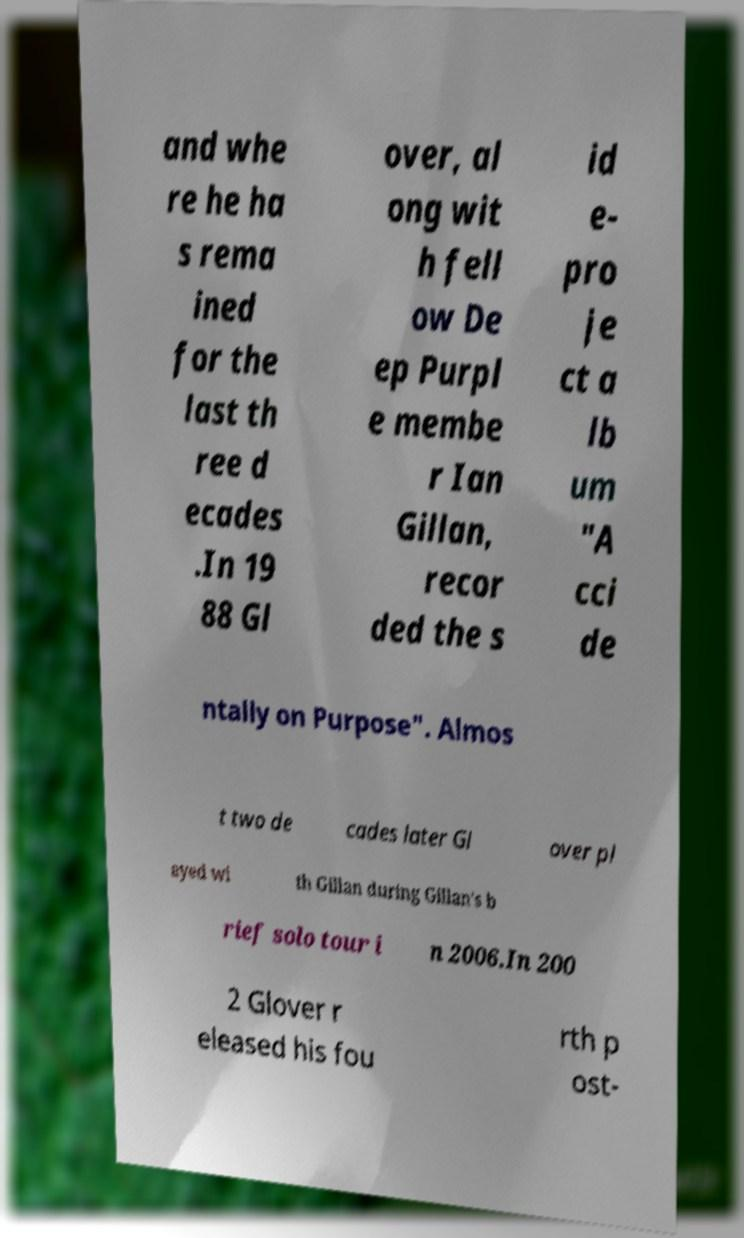Could you assist in decoding the text presented in this image and type it out clearly? and whe re he ha s rema ined for the last th ree d ecades .In 19 88 Gl over, al ong wit h fell ow De ep Purpl e membe r Ian Gillan, recor ded the s id e- pro je ct a lb um "A cci de ntally on Purpose". Almos t two de cades later Gl over pl ayed wi th Gillan during Gillan's b rief solo tour i n 2006.In 200 2 Glover r eleased his fou rth p ost- 